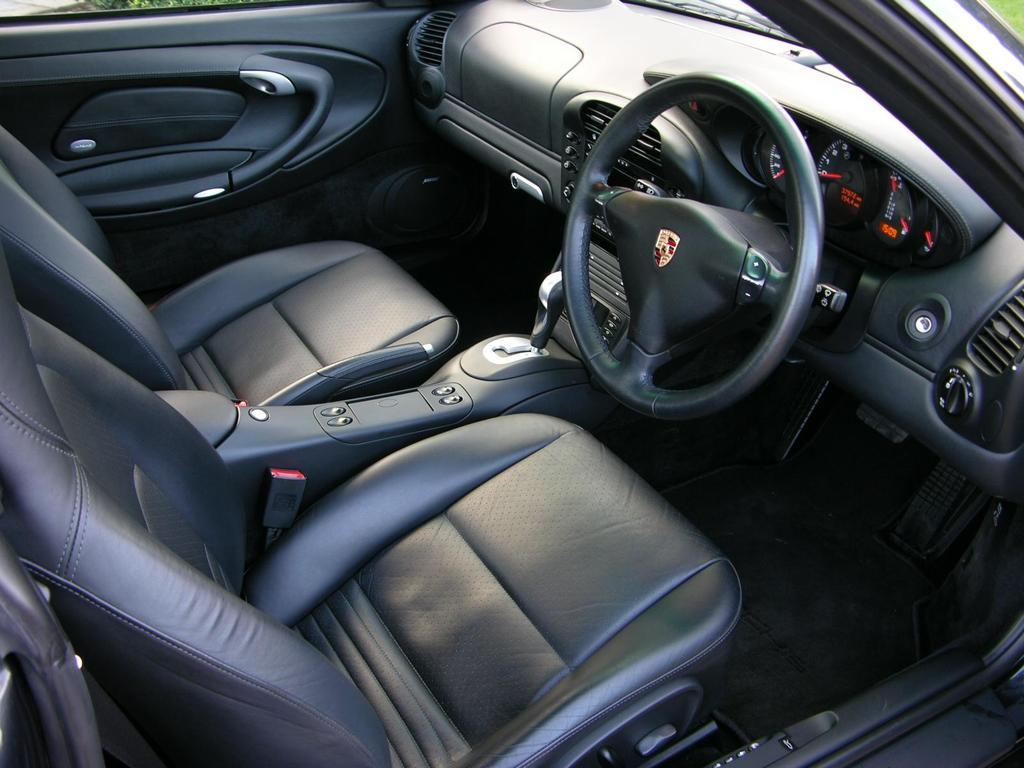What type of vehicle is shown in the image? The image shows an inside view of a car. Where is the steering wheel located in the car? The steering wheel is on the right side of the car. What electronic device is present in the car? An amplifier is present on the right side of the car. What is used to change gears in the car? A gear rod is visible on the right side of the car. How many seats are there in the car? There are two seats in the car. Is there a door on the left side of the car? Yes, there is a door on the left side of the car. What type of punishment is being administered to the driver in the image? There is no indication of any punishment being administered to the driver in the image. What time of day is it in the image, based on the hour? The image does not provide any information about the time of day or the hour. 